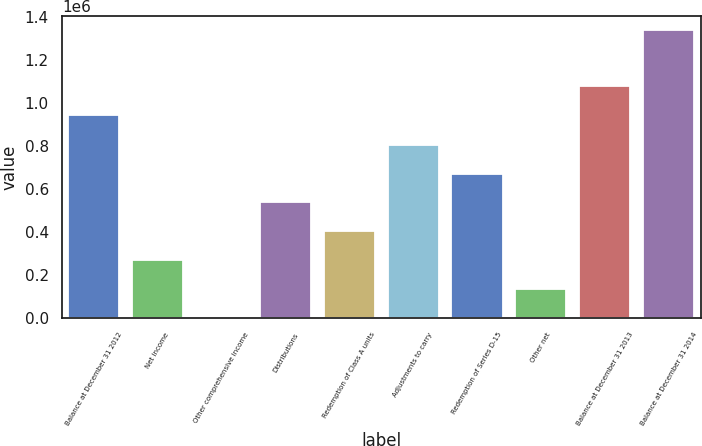Convert chart to OTSL. <chart><loc_0><loc_0><loc_500><loc_500><bar_chart><fcel>Balance at December 31 2012<fcel>Net income<fcel>Other comprehensive income<fcel>Distributions<fcel>Redemption of Class A units<fcel>Adjustments to carry<fcel>Redemption of Series D-15<fcel>Other net<fcel>Balance at December 31 2013<fcel>Balance at December 31 2014<nl><fcel>944152<fcel>271793<fcel>5296<fcel>538290<fcel>405041<fcel>804786<fcel>671538<fcel>138544<fcel>1.0774e+06<fcel>1.33778e+06<nl></chart> 